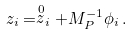<formula> <loc_0><loc_0><loc_500><loc_500>z _ { i } = \stackrel { 0 } { z } _ { i } + M _ { P } ^ { - 1 } \phi _ { i } \, .</formula> 